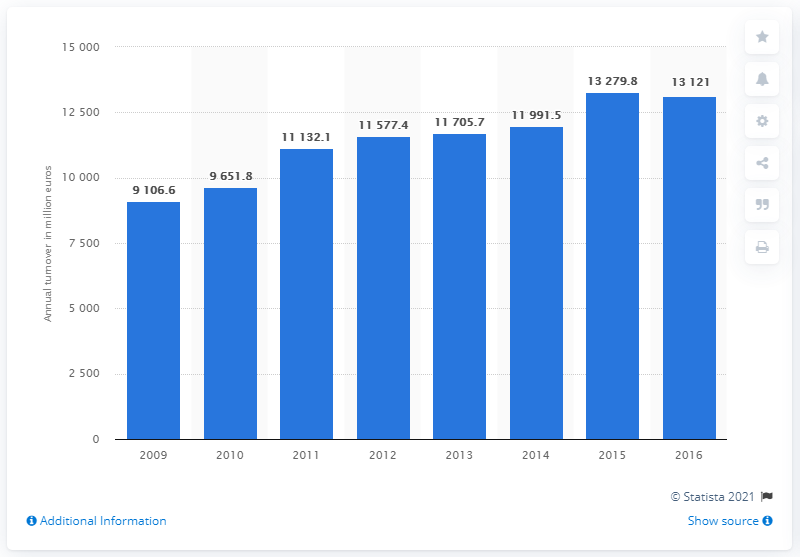List a handful of essential elements in this visual. The food and beverage service activities industry had a turnover of 131,211 in 2015. 